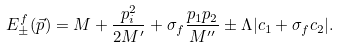Convert formula to latex. <formula><loc_0><loc_0><loc_500><loc_500>E ^ { f } _ { \pm } ( \vec { p } ) = M + \frac { p _ { i } ^ { 2 } } { 2 M ^ { \prime } } + \sigma _ { f } \frac { p _ { 1 } p _ { 2 } } { M ^ { \prime \prime } } \pm \Lambda | c _ { 1 } + \sigma _ { f } c _ { 2 } | .</formula> 